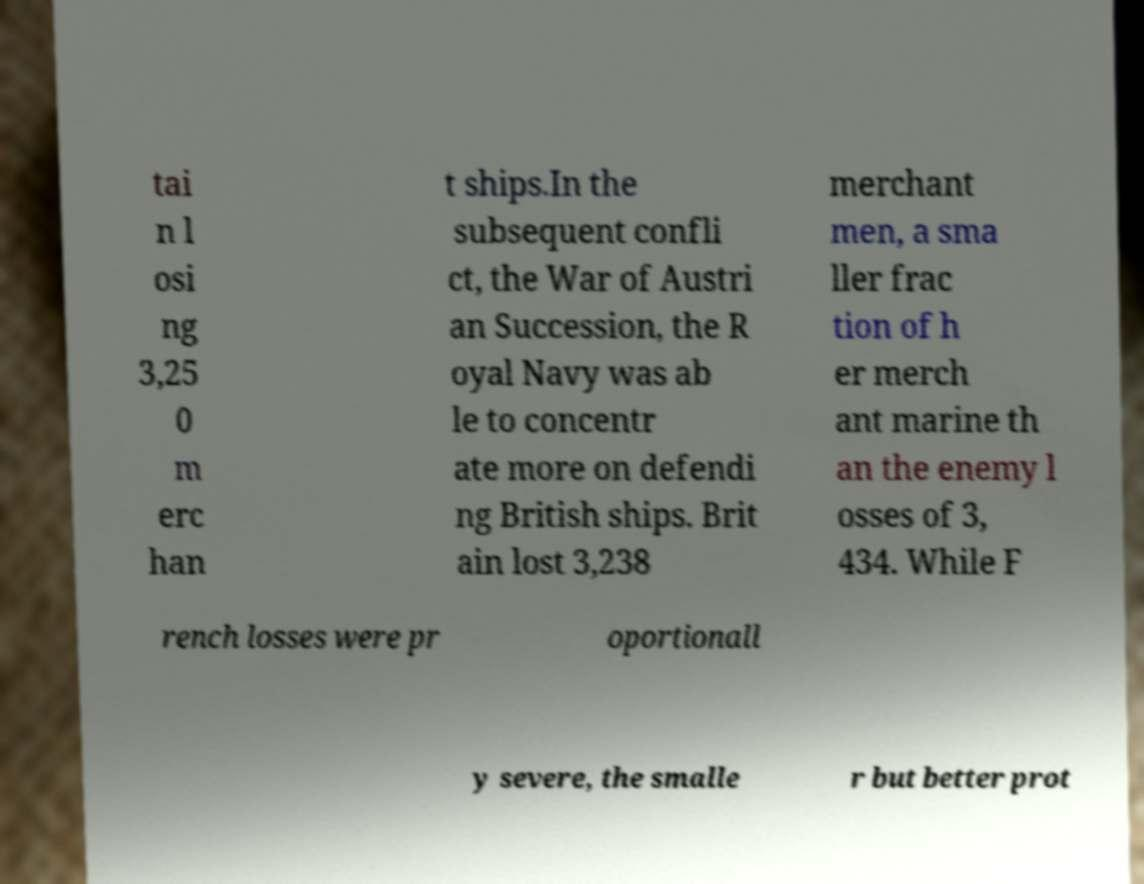There's text embedded in this image that I need extracted. Can you transcribe it verbatim? tai n l osi ng 3,25 0 m erc han t ships.In the subsequent confli ct, the War of Austri an Succession, the R oyal Navy was ab le to concentr ate more on defendi ng British ships. Brit ain lost 3,238 merchant men, a sma ller frac tion of h er merch ant marine th an the enemy l osses of 3, 434. While F rench losses were pr oportionall y severe, the smalle r but better prot 